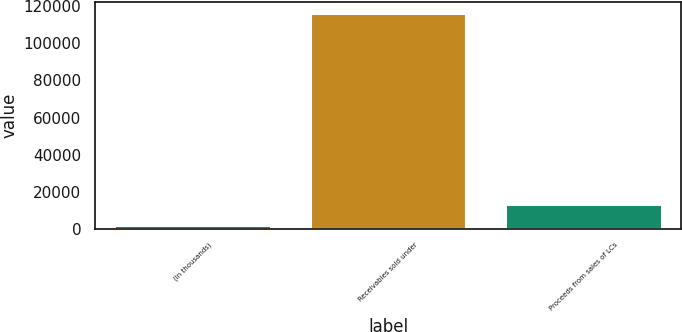Convert chart. <chart><loc_0><loc_0><loc_500><loc_500><bar_chart><fcel>(In thousands)<fcel>Receivables sold under<fcel>Proceeds from sales of LCs<nl><fcel>2014<fcel>116292<fcel>13441.8<nl></chart> 